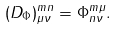<formula> <loc_0><loc_0><loc_500><loc_500>( D _ { \Phi } ) ^ { m n } _ { \mu \nu } = \Phi ^ { m \mu } _ { n \nu } .</formula> 